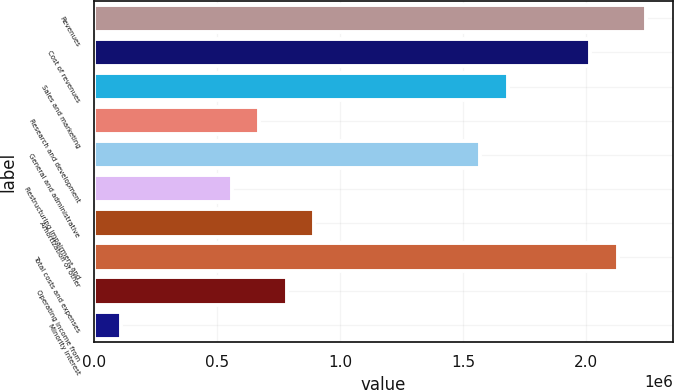Convert chart to OTSL. <chart><loc_0><loc_0><loc_500><loc_500><bar_chart><fcel>Revenues<fcel>Cost of revenues<fcel>Sales and marketing<fcel>Research and development<fcel>General and administrative<fcel>Restructuring impairment and<fcel>Amortization of other<fcel>Total costs and expenses<fcel>Operating income from<fcel>Minority interest<nl><fcel>2.24119e+06<fcel>2.01707e+06<fcel>1.68089e+06<fcel>672357<fcel>1.56883e+06<fcel>560298<fcel>896476<fcel>2.12913e+06<fcel>784417<fcel>112060<nl></chart> 